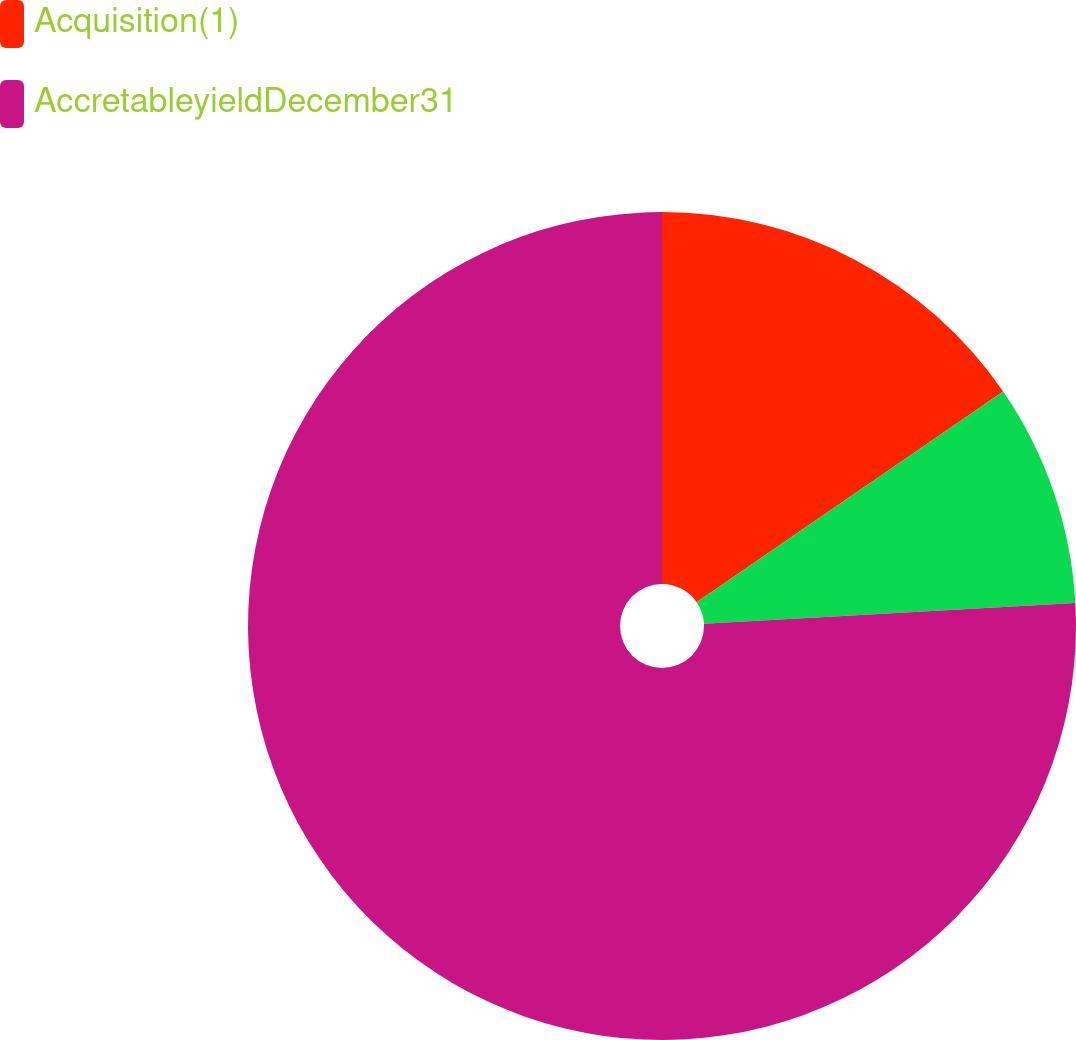Convert chart. <chart><loc_0><loc_0><loc_500><loc_500><pie_chart><fcel>Acquisition(1)<fcel>Unnamed: 1<fcel>AccretableyieldDecember31<nl><fcel>15.42%<fcel>8.7%<fcel>75.89%<nl></chart> 